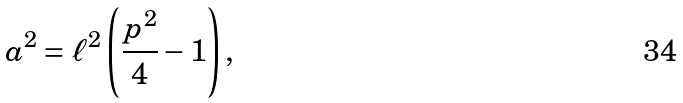<formula> <loc_0><loc_0><loc_500><loc_500>a ^ { 2 } = \ell ^ { 2 } \left ( \frac { p ^ { 2 } } { 4 } - 1 \right ) ,</formula> 